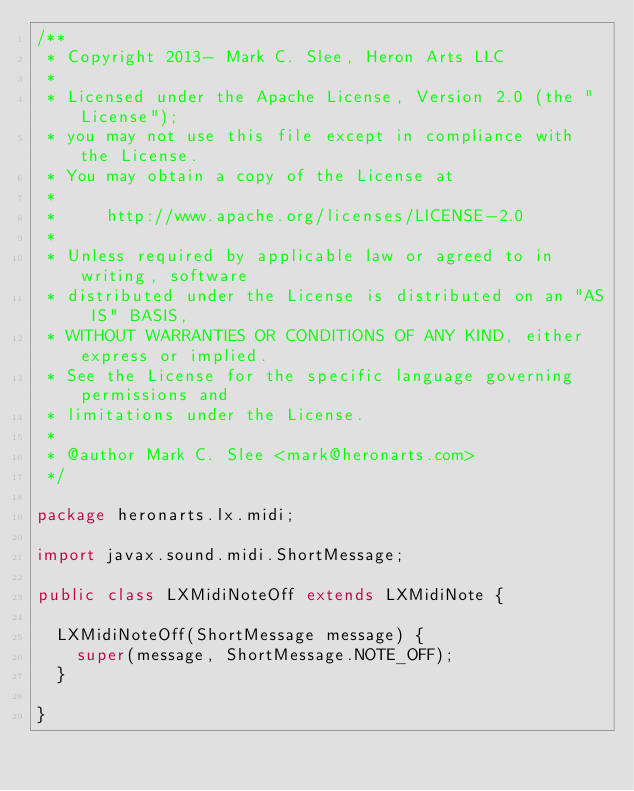<code> <loc_0><loc_0><loc_500><loc_500><_Java_>/**
 * Copyright 2013- Mark C. Slee, Heron Arts LLC
 *
 * Licensed under the Apache License, Version 2.0 (the "License");
 * you may not use this file except in compliance with the License.
 * You may obtain a copy of the License at
 *
 *     http://www.apache.org/licenses/LICENSE-2.0
 *
 * Unless required by applicable law or agreed to in writing, software
 * distributed under the License is distributed on an "AS IS" BASIS,
 * WITHOUT WARRANTIES OR CONDITIONS OF ANY KIND, either express or implied.
 * See the License for the specific language governing permissions and
 * limitations under the License.
 *
 * @author Mark C. Slee <mark@heronarts.com>
 */

package heronarts.lx.midi;

import javax.sound.midi.ShortMessage;

public class LXMidiNoteOff extends LXMidiNote {

  LXMidiNoteOff(ShortMessage message) {
    super(message, ShortMessage.NOTE_OFF);
  }

}
</code> 